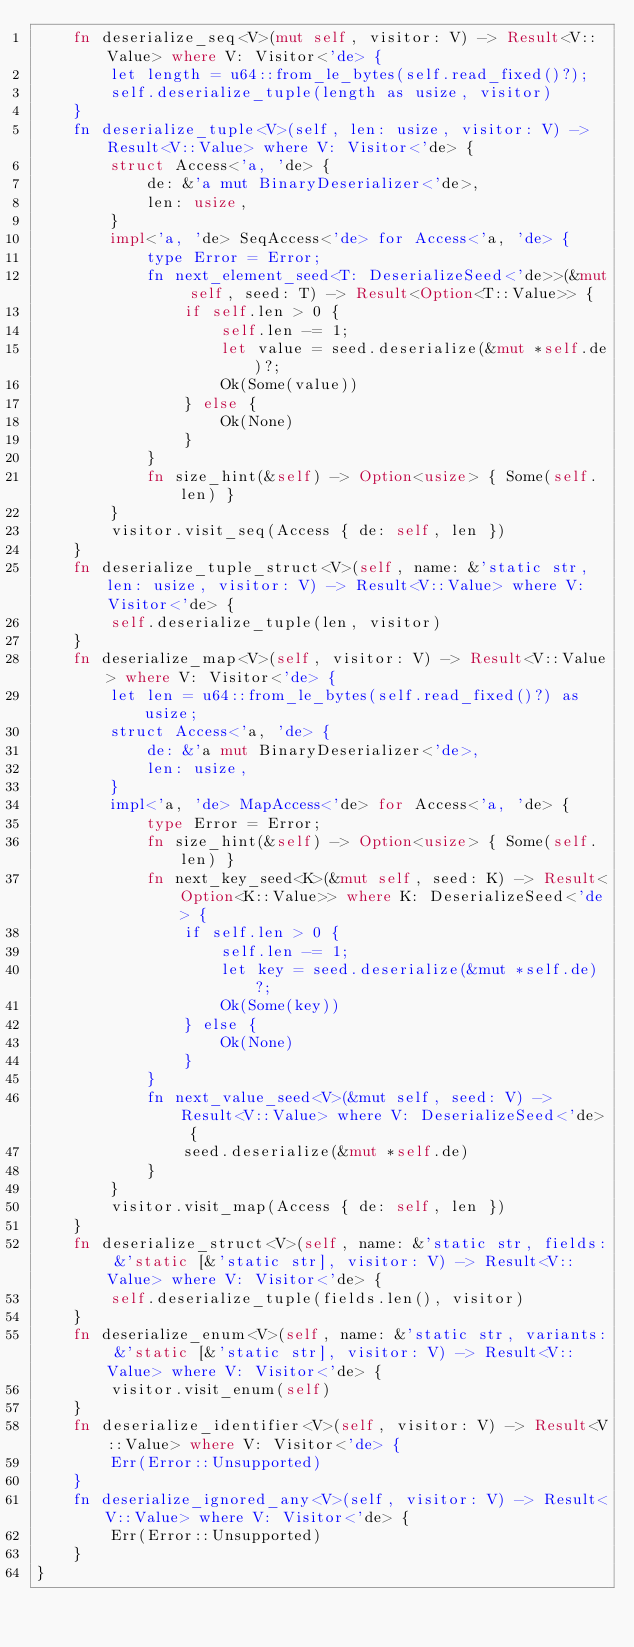<code> <loc_0><loc_0><loc_500><loc_500><_Rust_>    fn deserialize_seq<V>(mut self, visitor: V) -> Result<V::Value> where V: Visitor<'de> {
        let length = u64::from_le_bytes(self.read_fixed()?);
        self.deserialize_tuple(length as usize, visitor)
    }
    fn deserialize_tuple<V>(self, len: usize, visitor: V) -> Result<V::Value> where V: Visitor<'de> {
        struct Access<'a, 'de> {
            de: &'a mut BinaryDeserializer<'de>,
            len: usize,
        }
        impl<'a, 'de> SeqAccess<'de> for Access<'a, 'de> {
            type Error = Error;
            fn next_element_seed<T: DeserializeSeed<'de>>(&mut self, seed: T) -> Result<Option<T::Value>> {
                if self.len > 0 {
                    self.len -= 1;
                    let value = seed.deserialize(&mut *self.de)?;
                    Ok(Some(value))
                } else {
                    Ok(None)
                }
            }
            fn size_hint(&self) -> Option<usize> { Some(self.len) }
        }
        visitor.visit_seq(Access { de: self, len })
    }
    fn deserialize_tuple_struct<V>(self, name: &'static str, len: usize, visitor: V) -> Result<V::Value> where V: Visitor<'de> {
        self.deserialize_tuple(len, visitor)
    }
    fn deserialize_map<V>(self, visitor: V) -> Result<V::Value> where V: Visitor<'de> {
        let len = u64::from_le_bytes(self.read_fixed()?) as usize;
        struct Access<'a, 'de> {
            de: &'a mut BinaryDeserializer<'de>,
            len: usize,
        }
        impl<'a, 'de> MapAccess<'de> for Access<'a, 'de> {
            type Error = Error;
            fn size_hint(&self) -> Option<usize> { Some(self.len) }
            fn next_key_seed<K>(&mut self, seed: K) -> Result<Option<K::Value>> where K: DeserializeSeed<'de> {
                if self.len > 0 {
                    self.len -= 1;
                    let key = seed.deserialize(&mut *self.de)?;
                    Ok(Some(key))
                } else {
                    Ok(None)
                }
            }
            fn next_value_seed<V>(&mut self, seed: V) -> Result<V::Value> where V: DeserializeSeed<'de> {
                seed.deserialize(&mut *self.de)
            }
        }
        visitor.visit_map(Access { de: self, len })
    }
    fn deserialize_struct<V>(self, name: &'static str, fields: &'static [&'static str], visitor: V) -> Result<V::Value> where V: Visitor<'de> {
        self.deserialize_tuple(fields.len(), visitor)
    }
    fn deserialize_enum<V>(self, name: &'static str, variants: &'static [&'static str], visitor: V) -> Result<V::Value> where V: Visitor<'de> {
        visitor.visit_enum(self)
    }
    fn deserialize_identifier<V>(self, visitor: V) -> Result<V::Value> where V: Visitor<'de> {
        Err(Error::Unsupported)
    }
    fn deserialize_ignored_any<V>(self, visitor: V) -> Result<V::Value> where V: Visitor<'de> {
        Err(Error::Unsupported)
    }
}
</code> 